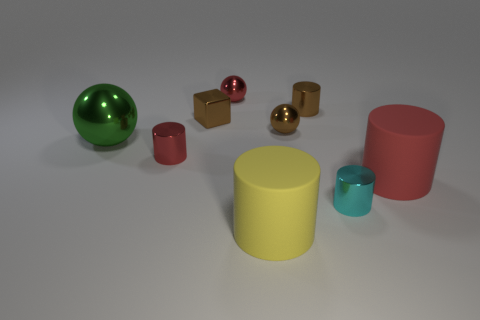Subtract 2 cylinders. How many cylinders are left? 3 Subtract all tiny brown shiny cylinders. How many cylinders are left? 4 Subtract all cyan cylinders. How many cylinders are left? 4 Subtract all gray cylinders. Subtract all yellow blocks. How many cylinders are left? 5 Add 1 small brown balls. How many objects exist? 10 Subtract all blocks. How many objects are left? 8 Subtract 1 brown balls. How many objects are left? 8 Subtract all rubber objects. Subtract all tiny brown blocks. How many objects are left? 6 Add 6 metallic cylinders. How many metallic cylinders are left? 9 Add 2 cyan rubber blocks. How many cyan rubber blocks exist? 2 